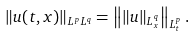Convert formula to latex. <formula><loc_0><loc_0><loc_500><loc_500>\| u ( t , x ) \| _ { L ^ { p } L ^ { q } } = \left \| \| u \| _ { L ^ { q } _ { x } } \right \| _ { L ^ { p } _ { t } } .</formula> 